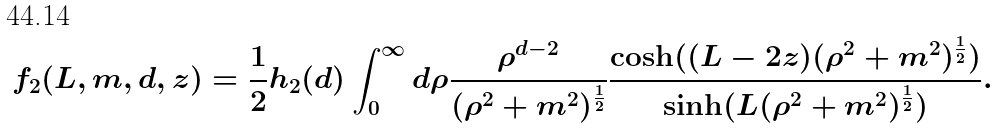<formula> <loc_0><loc_0><loc_500><loc_500>f _ { 2 } ( L , m , d , z ) = \frac { 1 } { 2 } h _ { 2 } ( d ) \int _ { 0 } ^ { \infty } d \rho \frac { \rho ^ { d - 2 } } { ( { \rho } ^ { 2 } + m ^ { 2 } ) ^ { \frac { 1 } { 2 } } } \frac { \cosh ( ( L - 2 z ) ( { \rho } ^ { 2 } + m ^ { 2 } ) ^ { \frac { 1 } { 2 } } ) } { \sinh ( L ( { \rho } ^ { 2 } + m ^ { 2 } ) ^ { \frac { 1 } { 2 } } ) } .</formula> 